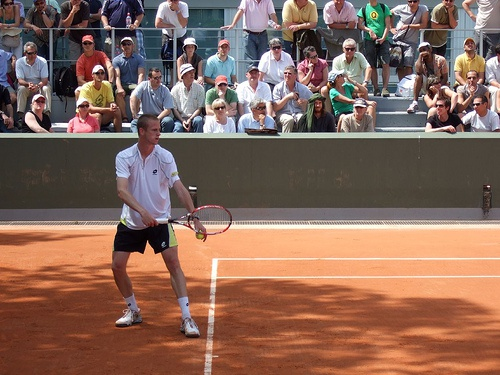Describe the objects in this image and their specific colors. I can see people in black, gray, darkgray, and lightgray tones, people in black, gray, and maroon tones, people in black, gray, lightgray, and darkgray tones, people in black, gray, white, darkgray, and brown tones, and people in black, maroon, and tan tones in this image. 